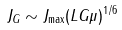Convert formula to latex. <formula><loc_0><loc_0><loc_500><loc_500>J _ { G } \sim J _ { \max } ( L G \mu ) ^ { 1 / 6 }</formula> 